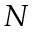Convert formula to latex. <formula><loc_0><loc_0><loc_500><loc_500>N</formula> 